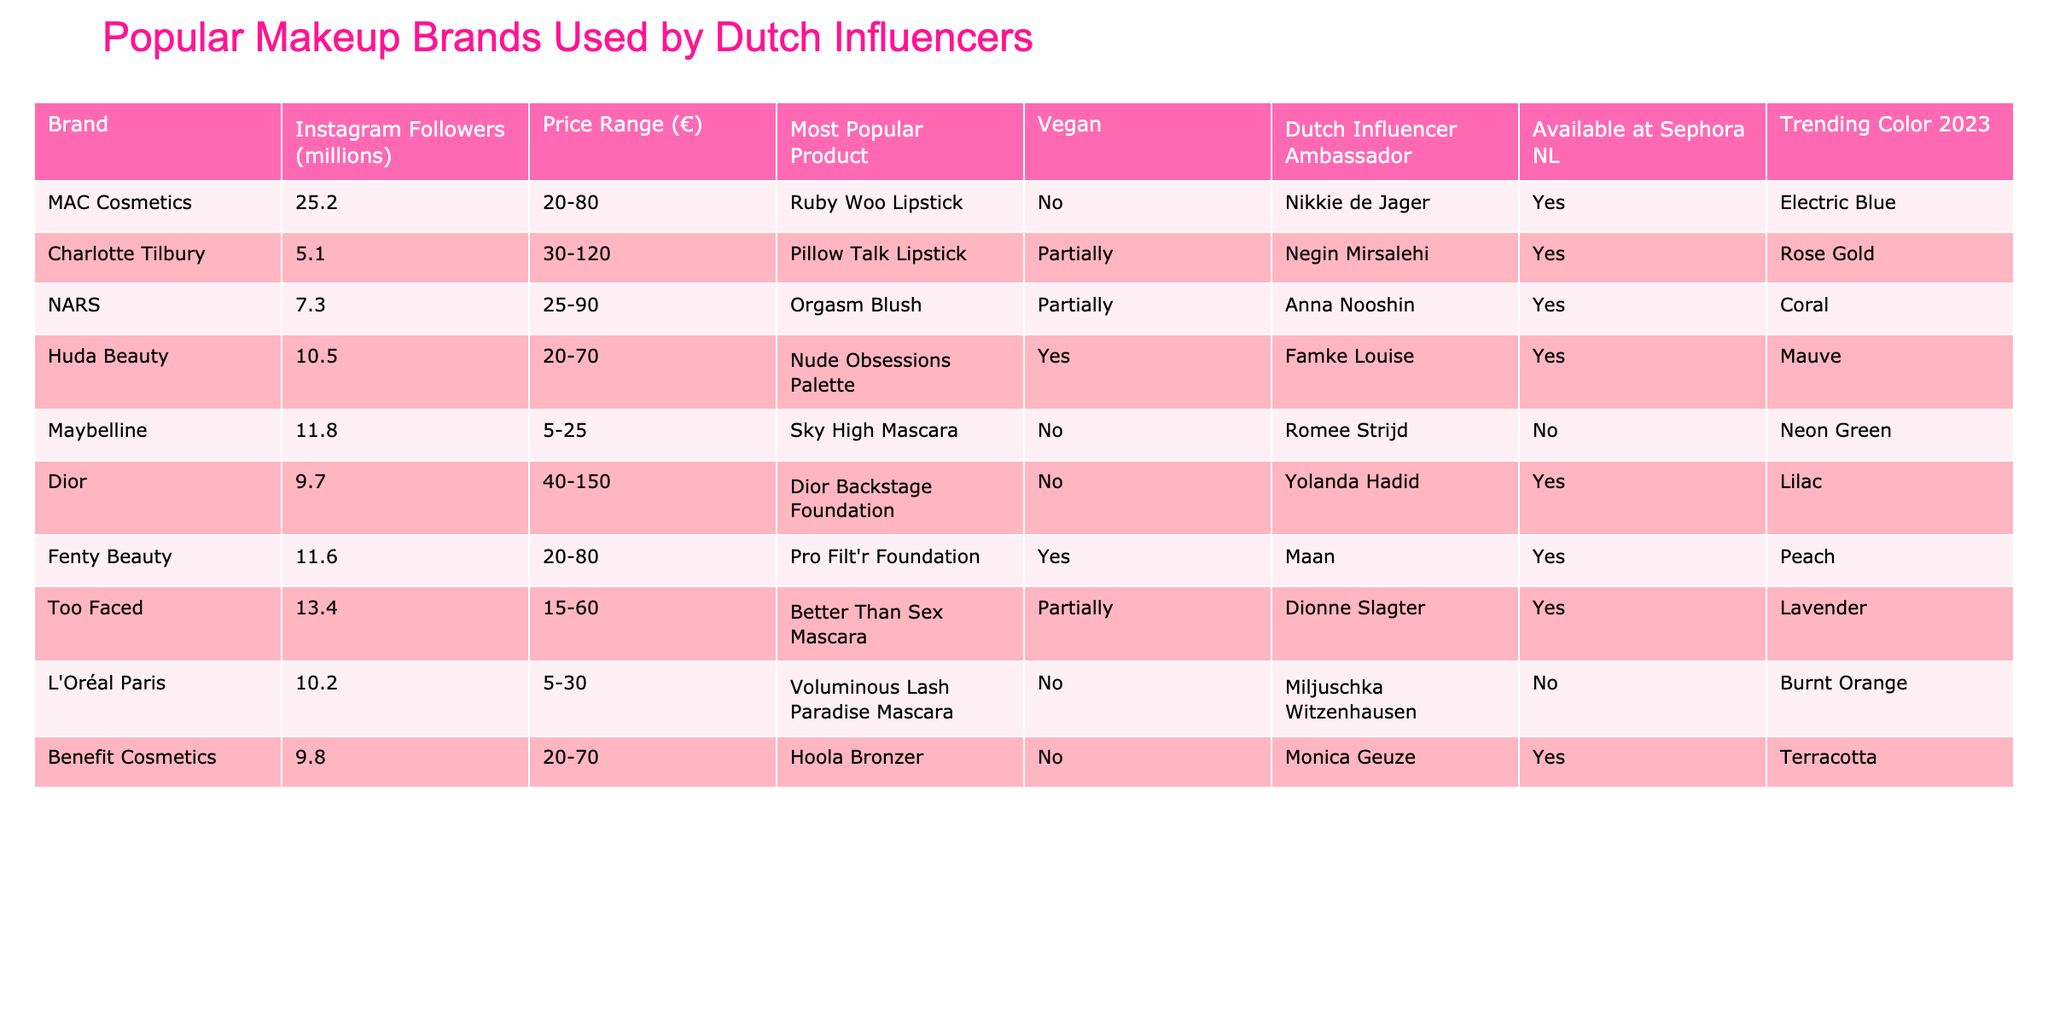What is the price range of MAC Cosmetics products? The price range for MAC Cosmetics is listed in the table under "Price Range," which shows a range of €20 to €80.
Answer: €20-80 Which brand has the most Instagram followers? The number of Instagram followers for each brand is included in the table. MAC Cosmetics has 25.2 million followers, which is the highest among the listed brands.
Answer: MAC Cosmetics Is Maybelline available at Sephora NL? The table indicates whether each brand is available at Sephora NL. Under Maybelline, it states "No," meaning it is not available at that store.
Answer: No What is the most popular product of Dior? The table specifies the most popular product for each brand. For Dior, the most popular product is the Dior Backstage Foundation.
Answer: Dior Backstage Foundation How many brands have vegan products? The vegan status of each brand is noted in the table. There are 4 brands with "Yes" for vegan, which are Huda Beauty and Fenty Beauty, while MAC, Maybelline, Dior, and L'Oréal Paris are not vegan.
Answer: 4 Which brand offers the most expensive product? The price ranges are compared, and it is determined that Charlotte Tilbury has the highest price range at €30 to €120.
Answer: Charlotte Tilbury What is the trending color for Fenty Beauty in 2023? The table lists the trending colors for each brand. For Fenty Beauty, the trending color for 2023 is Peach.
Answer: Peach What brands have Dutch influencer ambassadors? By looking at the "Dutch Influencer Ambassador" column, the brands with "Yes" include MAC, NARS, Huda Beauty, Too Faced, and Benefit Cosmetics. There are a total of 5 brands with ambassadors.
Answer: 5 brands Which brand has a partially vegan product and is available at Sephora NL? The table shows that Charlotte Tilbury and Too Faced are both partially vegan and listed as available at Sephora NL.
Answer: Charlotte Tilbury and Too Faced What is the average price range of brands that are available at Sephora NL? The brands available at Sephora NL are MAC, Charlotte Tilbury, NARS, Huda Beauty, Dior, Fenty Beauty, Too Faced, and Benefit Cosmetics. The corresponding price ranges are €20-80, €30-120, €25-90, €20-70, €40-150, €20-80, €15-60, and €20-70. The average is calculated by converting ranges to numeric values, summing the lower bounds (20 + 30 + 25 + 20 + 40 + 20 + 15 + 20) = 220, and dividing by 8 gives 27.5. The same is done for the upper bounds. The overall average price range can be approximately pulled from this data set.
Answer: Approximately €27.5 Which trending color for 2023 is linked to the most expensive brand? Charlotte Tilbury, the brand with the most expensive price range (€30-120), has a trending color of Rose Gold for 2023.
Answer: Rose Gold 